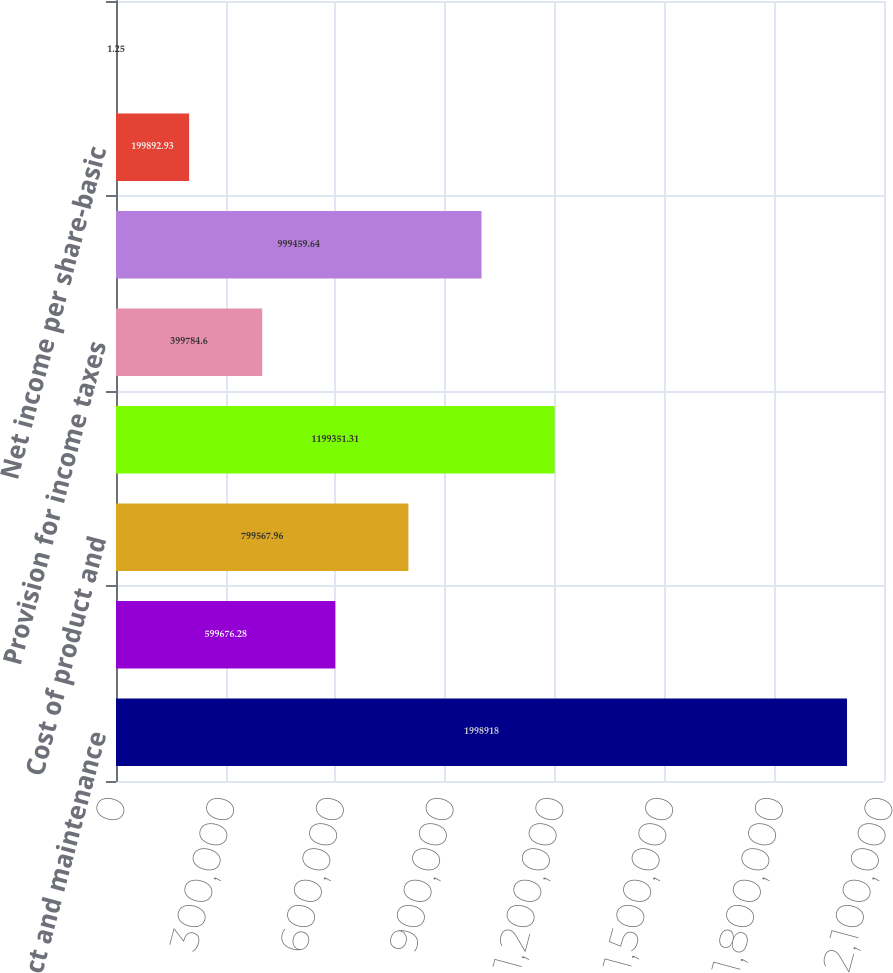Convert chart to OTSL. <chart><loc_0><loc_0><loc_500><loc_500><bar_chart><fcel>Product and maintenance<fcel>Services revenue<fcel>Cost of product and<fcel>Marketing and sales expense<fcel>Provision for income taxes<fcel>Net income<fcel>Net income per share-basic<fcel>Net income per share-diluted<nl><fcel>1.99892e+06<fcel>599676<fcel>799568<fcel>1.19935e+06<fcel>399785<fcel>999460<fcel>199893<fcel>1.25<nl></chart> 